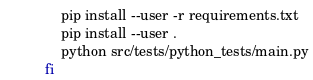Convert code to text. <code><loc_0><loc_0><loc_500><loc_500><_Bash_>    pip install --user -r requirements.txt
    pip install --user .
    python src/tests/python_tests/main.py
fi
</code> 